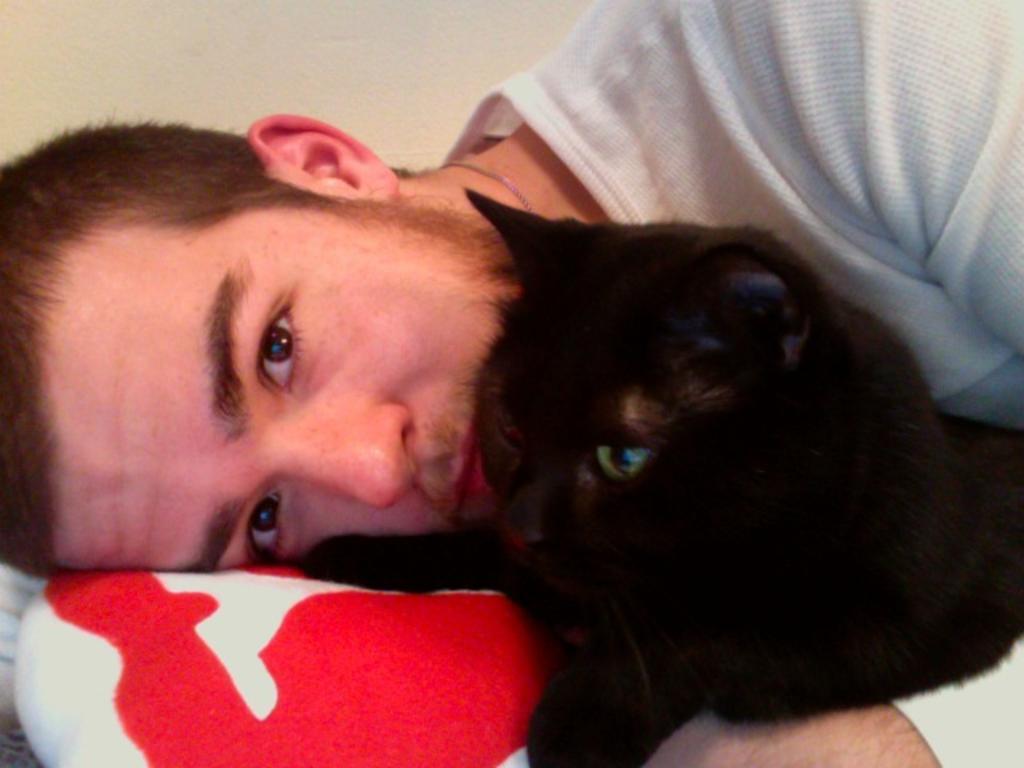Could you give a brief overview of what you see in this image? A man is sleeping with a black cat cuddled in his hand. 